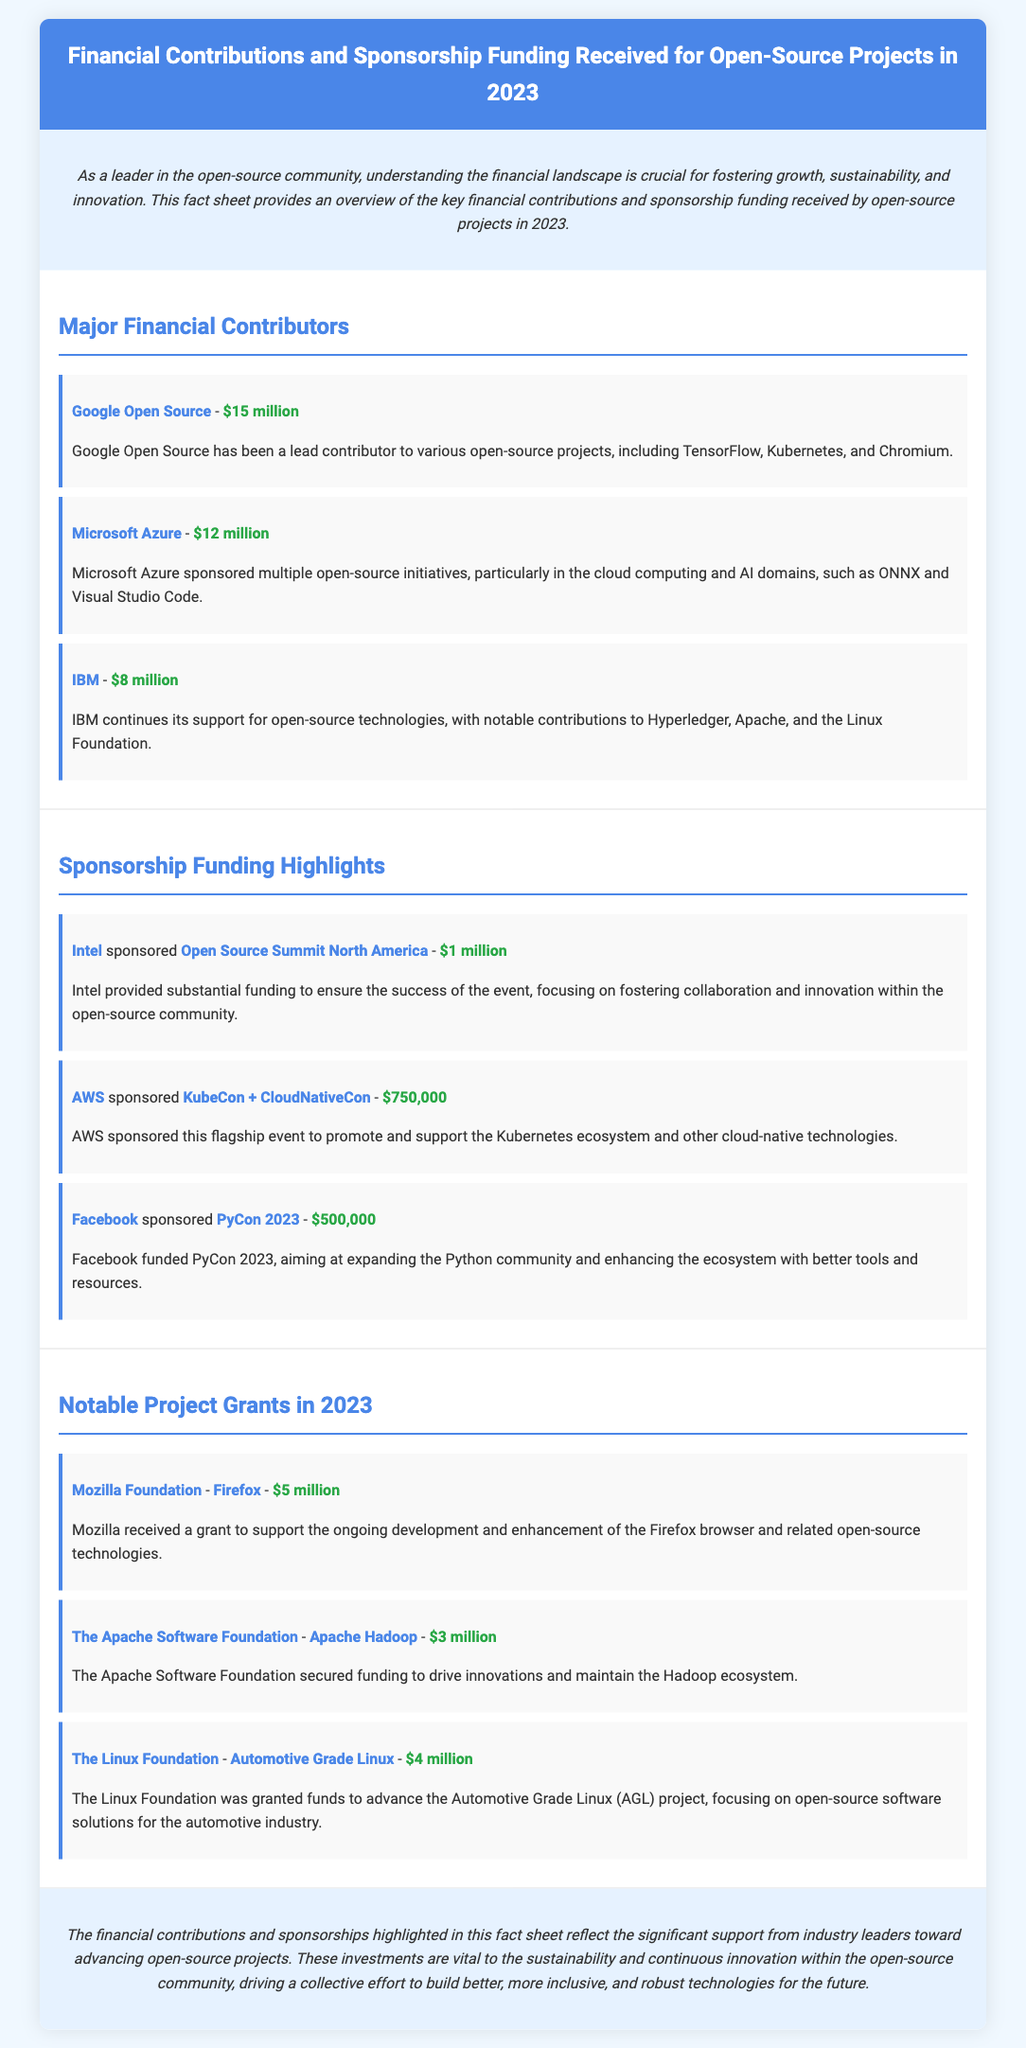What is the total funding received from Google Open Source? The document states that Google Open Source contributed $15 million to open-source projects.
Answer: $15 million Who sponsored Open Source Summit North America? According to the document, Intel sponsored the Open Source Summit North America event with funding.
Answer: Intel What is the amount of sponsorship funding provided by AWS for KubeCon + CloudNativeCon? The document indicates that AWS sponsored the event for $750,000.
Answer: $750,000 Which organization received a grant for the Firefox project? The document specifies that the Mozilla Foundation was the organization granted funding for Firefox.
Answer: Mozilla Foundation What is the total amount contributed by the three major financial contributors mentioned? The sum of the contributions from Google Open Source, Microsoft Azure, and IBM is calculated as $15 million + $12 million + $8 million = $35 million.
Answer: $35 million Who funded PyCon 2023? The document states that Facebook provided funding for PyCon 2023.
Answer: Facebook What project did The Linux Foundation receive funding for? The document mentions that The Linux Foundation received funding for Automotive Grade Linux.
Answer: Automotive Grade Linux What was the amount of funding for Apache Hadoop? The document states that The Apache Software Foundation secured $3 million for Apache Hadoop.
Answer: $3 million What is the purpose of the financial contributions highlighted in the fact sheet? The document mentions that these contributions support the sustainability and continuous innovation within the open-source community.
Answer: Sustainability and continuous innovation 